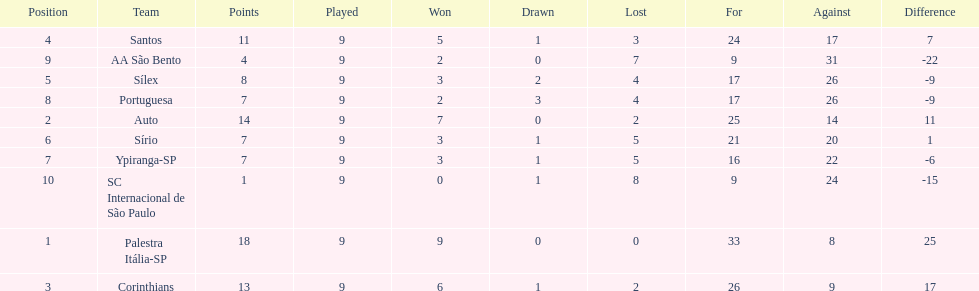Which team was the top scoring team? Palestra Itália-SP. 